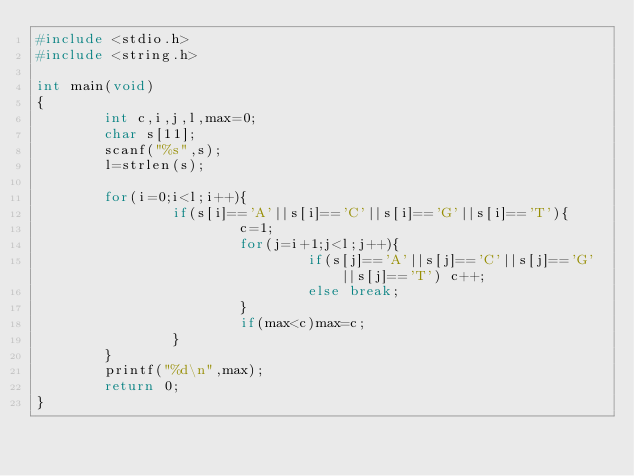<code> <loc_0><loc_0><loc_500><loc_500><_C_>#include <stdio.h>
#include <string.h>

int main(void)
{
        int c,i,j,l,max=0;
        char s[11];
        scanf("%s",s);
        l=strlen(s);

        for(i=0;i<l;i++){
                if(s[i]=='A'||s[i]=='C'||s[i]=='G'||s[i]=='T'){
                        c=1;
                        for(j=i+1;j<l;j++){
                                if(s[j]=='A'||s[j]=='C'||s[j]=='G'||s[j]=='T') c++;
                                else break;
                        }
                        if(max<c)max=c;
                }
        }
        printf("%d\n",max);
        return 0;
}
</code> 